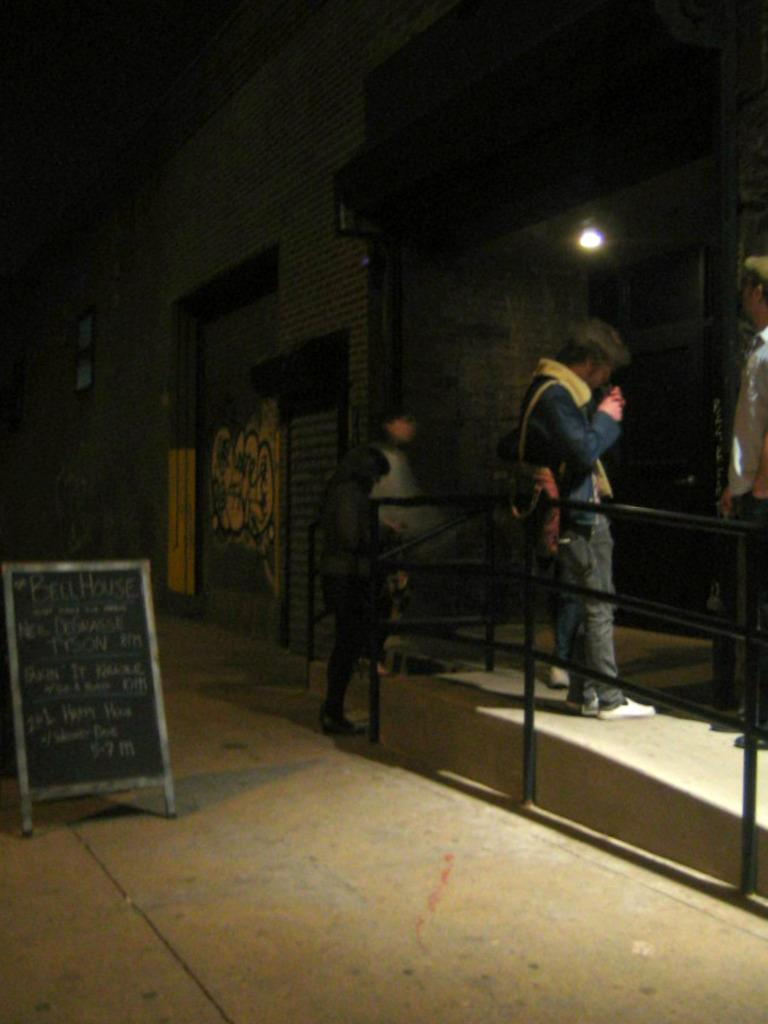How many persons are in the image? There are three persons in the image. What is the fence used for in the image? The fence is a barrier or divider in the image. What is the purpose of the board in the image? The purpose of the board in the image is not clear from the facts provided, but it could be used for displaying information or as a surface for writing or drawing. What is the function of the light in the image? The light in the image provides illumination. What is the wall used for in the image? The wall in the image is a structural element that provides support and encloses the space. Can you see a toad smashing into the wall in the image? There is no toad or any indication of a smashing event in the image. 